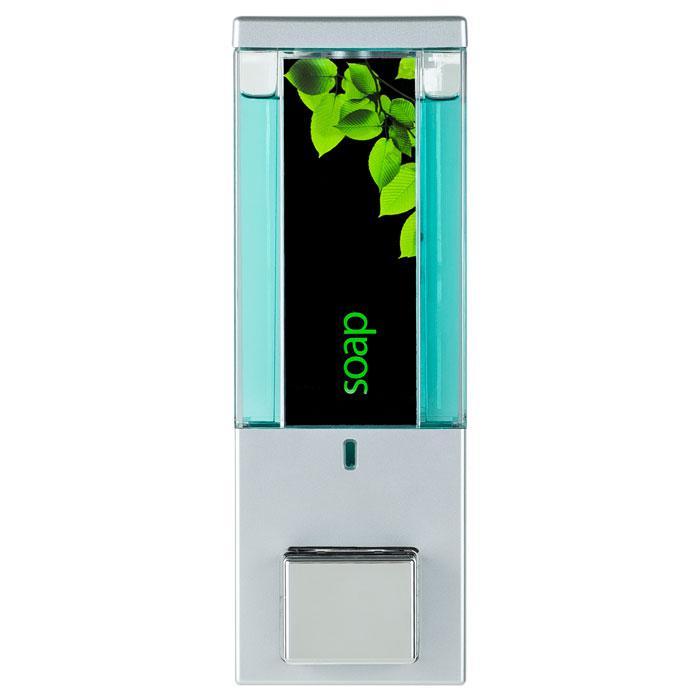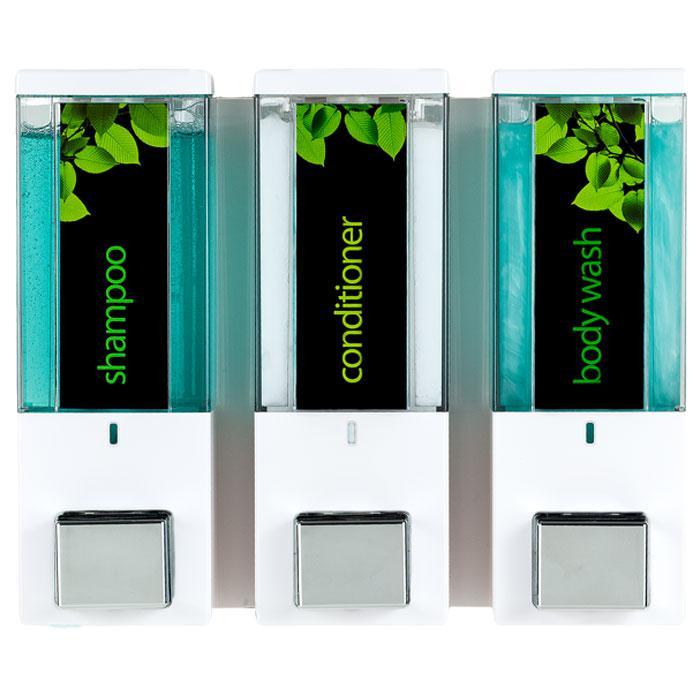The first image is the image on the left, the second image is the image on the right. Examine the images to the left and right. Is the description "There are more dispensers in the right image than in the left image." accurate? Answer yes or no. Yes. The first image is the image on the left, the second image is the image on the right. Evaluate the accuracy of this statement regarding the images: "The left image contains both a shampoo container and a body wash container.". Is it true? Answer yes or no. No. 